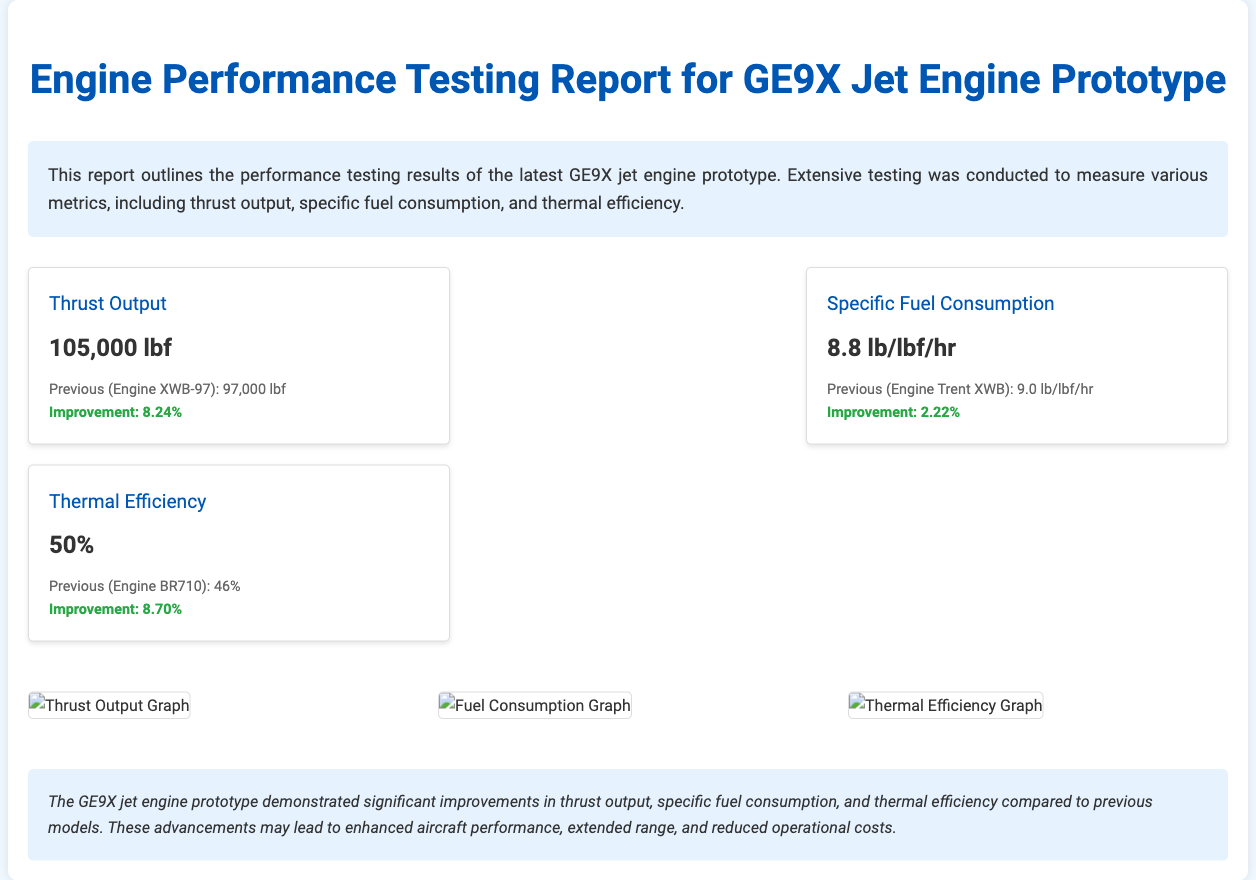What is the thrust output of the GE9X jet engine prototype? The thrust output is stated as 105,000 lbf in the metrics section of the report.
Answer: 105,000 lbf What is the specific fuel consumption of the engine? The specific fuel consumption is listed as 8.8 lb/lbf/hr in the metrics section.
Answer: 8.8 lb/lbf/hr What is the thermal efficiency of the GE9X jet engine? The thermal efficiency is mentioned as 50% in the report.
Answer: 50% What was the improvement percentage in thrust output compared to the previous engine? The report states an improvement of 8.24% in thrust output compared to the previous engine.
Answer: 8.24% Which previous engine had a thrust output of 97,000 lbf? The previous engine is identified as the Engine XWB-97 in the comparison data.
Answer: Engine XWB-97 What type of graphs are included in the report? The report includes graphs for thrust output, fuel consumption, and thermal efficiency.
Answer: Thrust output, fuel consumption, and thermal efficiency What is the purpose of the GE9X jet engine performance report? The purpose is to outline the performance testing results of the latest jet engine prototype.
Answer: To outline performance testing results What are the expected outcomes of the improvements mentioned in the report? The expected outcomes include enhanced aircraft performance, extended range, and reduced operational costs.
Answer: Enhanced aircraft performance, extended range, and reduced operational costs 